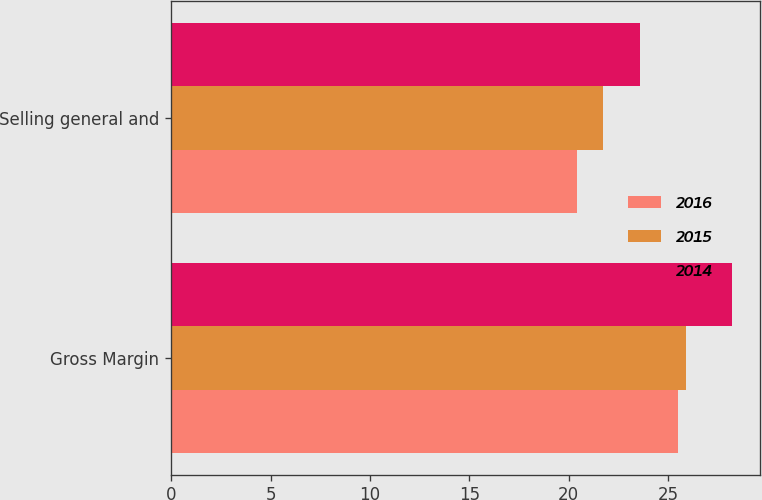<chart> <loc_0><loc_0><loc_500><loc_500><stacked_bar_chart><ecel><fcel>Gross Margin<fcel>Selling general and<nl><fcel>2016<fcel>25.5<fcel>20.4<nl><fcel>2015<fcel>25.9<fcel>21.7<nl><fcel>2014<fcel>28.2<fcel>23.6<nl></chart> 